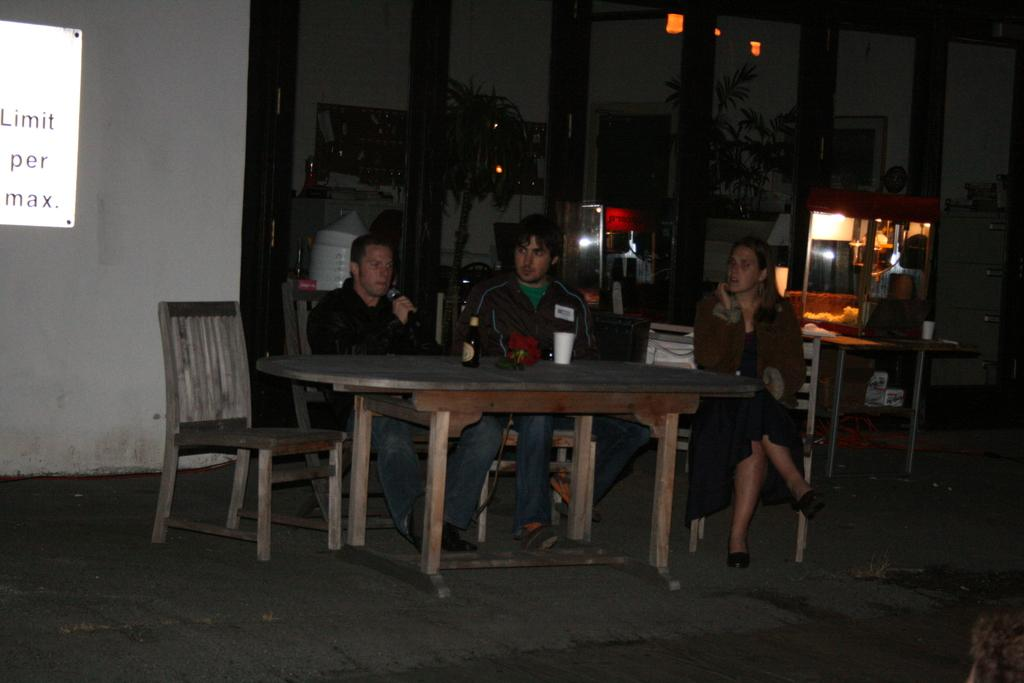How many people are seated in the image? There are three people seated in the image. What are the people sitting on? The people are seated on chairs. What can be seen on the table in the image? There is a beer bottle and a glass on the table. What is visible in the background of the image? There are plants visible in the background. What type of event is taking place in the image? There is no indication of an event taking place in the image; it simply shows three people seated with a beer bottle and a glass on the table. 